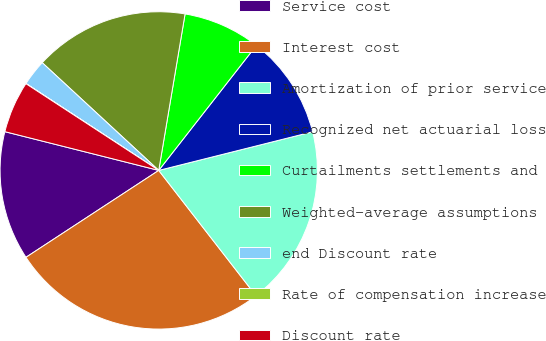Convert chart. <chart><loc_0><loc_0><loc_500><loc_500><pie_chart><fcel>Service cost<fcel>Interest cost<fcel>Amortization of prior service<fcel>Recognized net actuarial loss<fcel>Curtailments settlements and<fcel>Weighted-average assumptions<fcel>end Discount rate<fcel>Rate of compensation increase<fcel>Discount rate<nl><fcel>13.15%<fcel>26.28%<fcel>18.41%<fcel>10.53%<fcel>7.9%<fcel>15.78%<fcel>2.65%<fcel>0.02%<fcel>5.28%<nl></chart> 